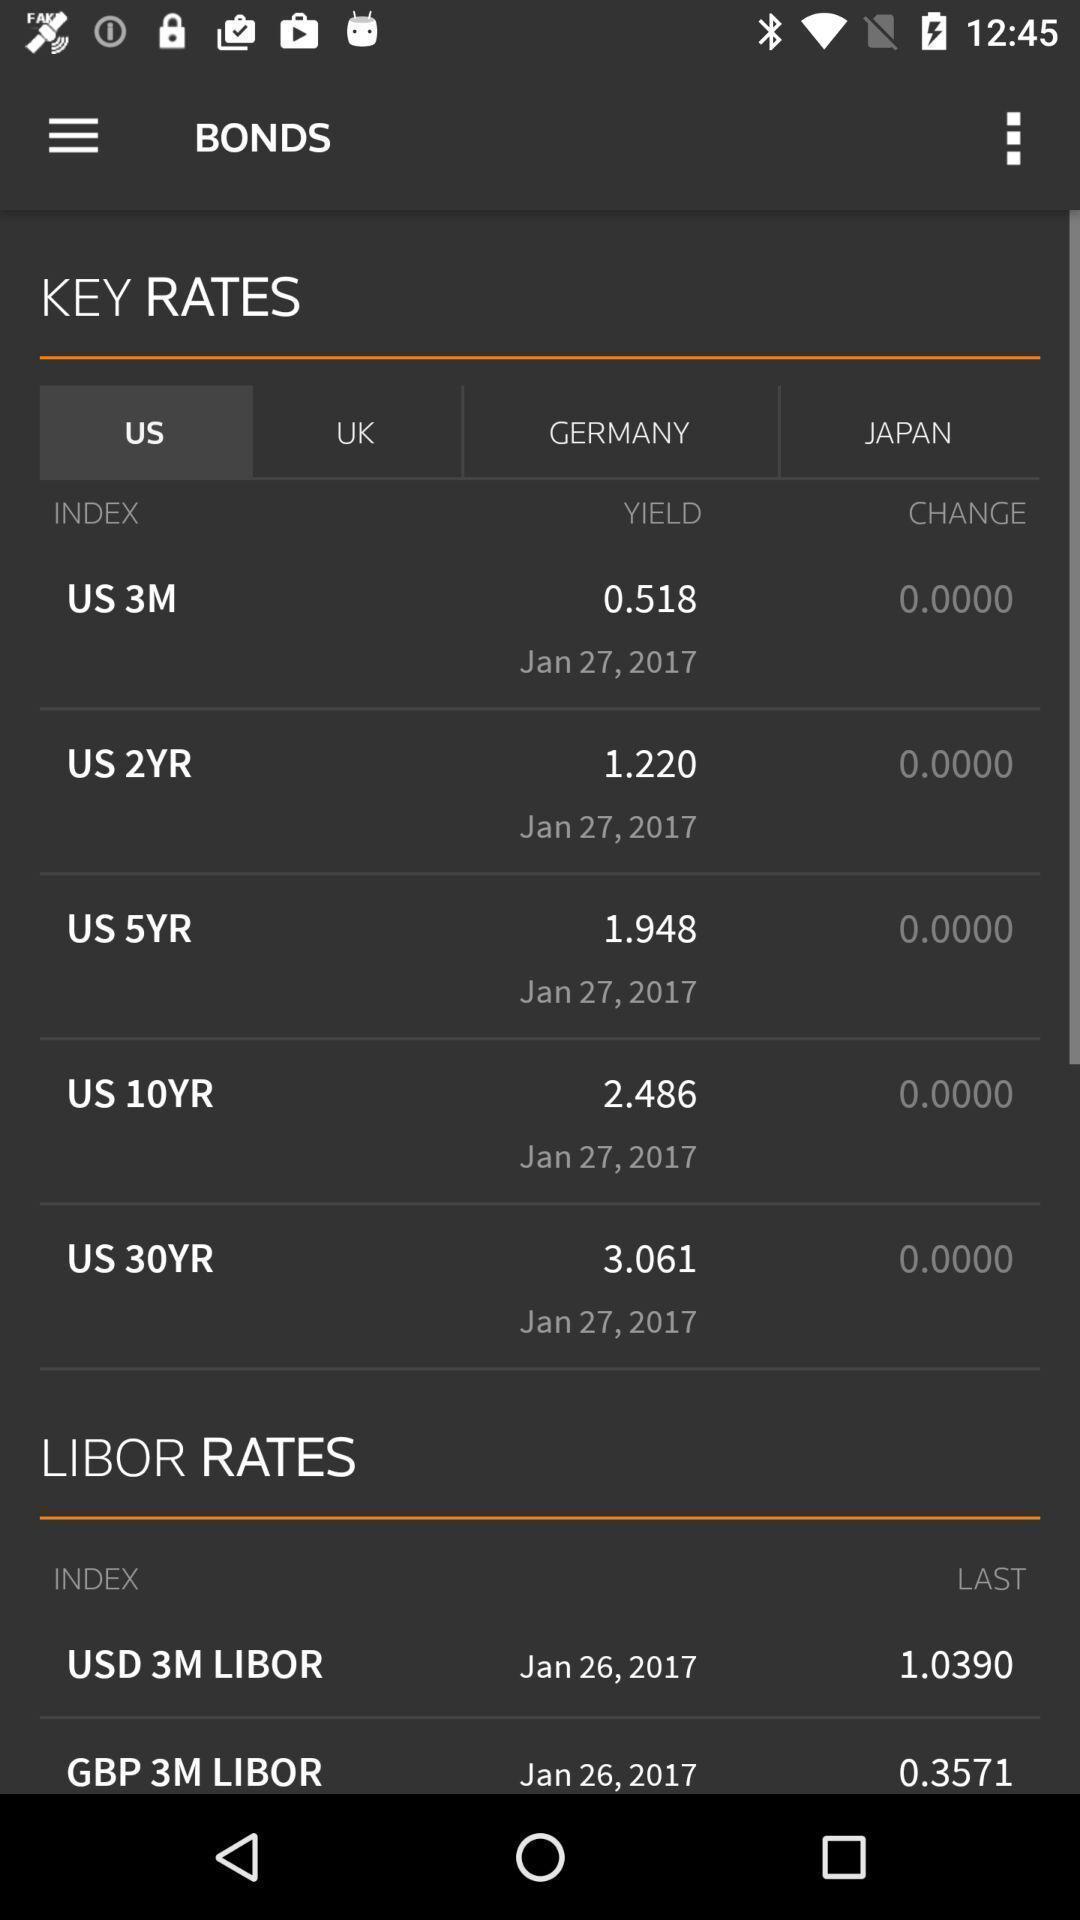Describe the content in this image. Screen showing all the rates. 